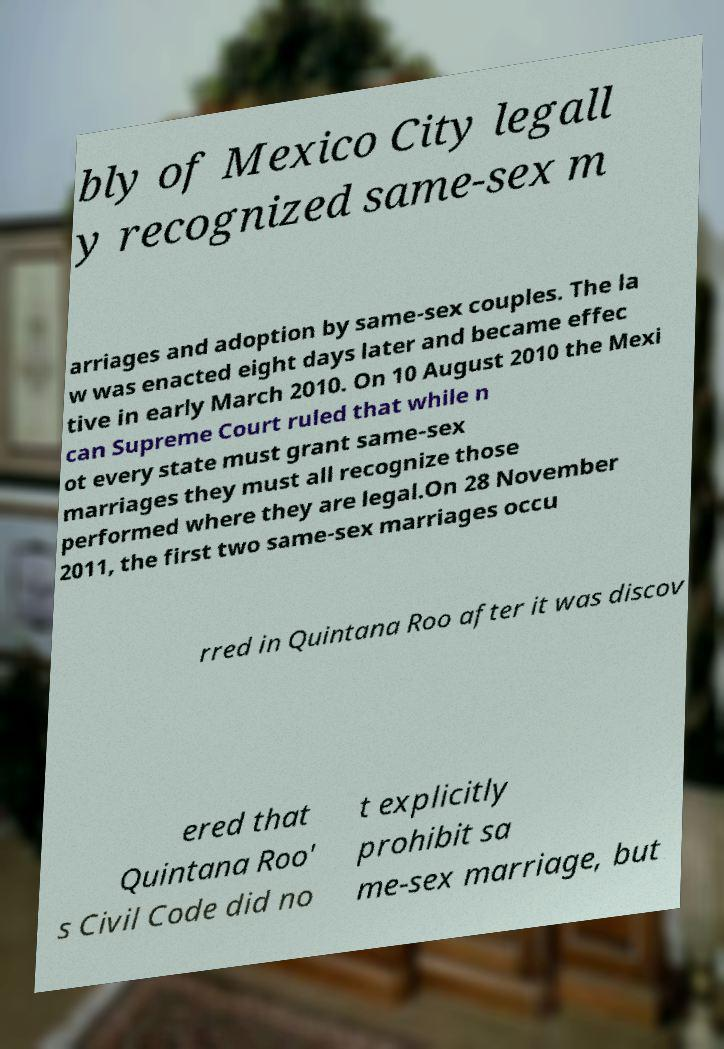Please identify and transcribe the text found in this image. bly of Mexico City legall y recognized same-sex m arriages and adoption by same-sex couples. The la w was enacted eight days later and became effec tive in early March 2010. On 10 August 2010 the Mexi can Supreme Court ruled that while n ot every state must grant same-sex marriages they must all recognize those performed where they are legal.On 28 November 2011, the first two same-sex marriages occu rred in Quintana Roo after it was discov ered that Quintana Roo' s Civil Code did no t explicitly prohibit sa me-sex marriage, but 